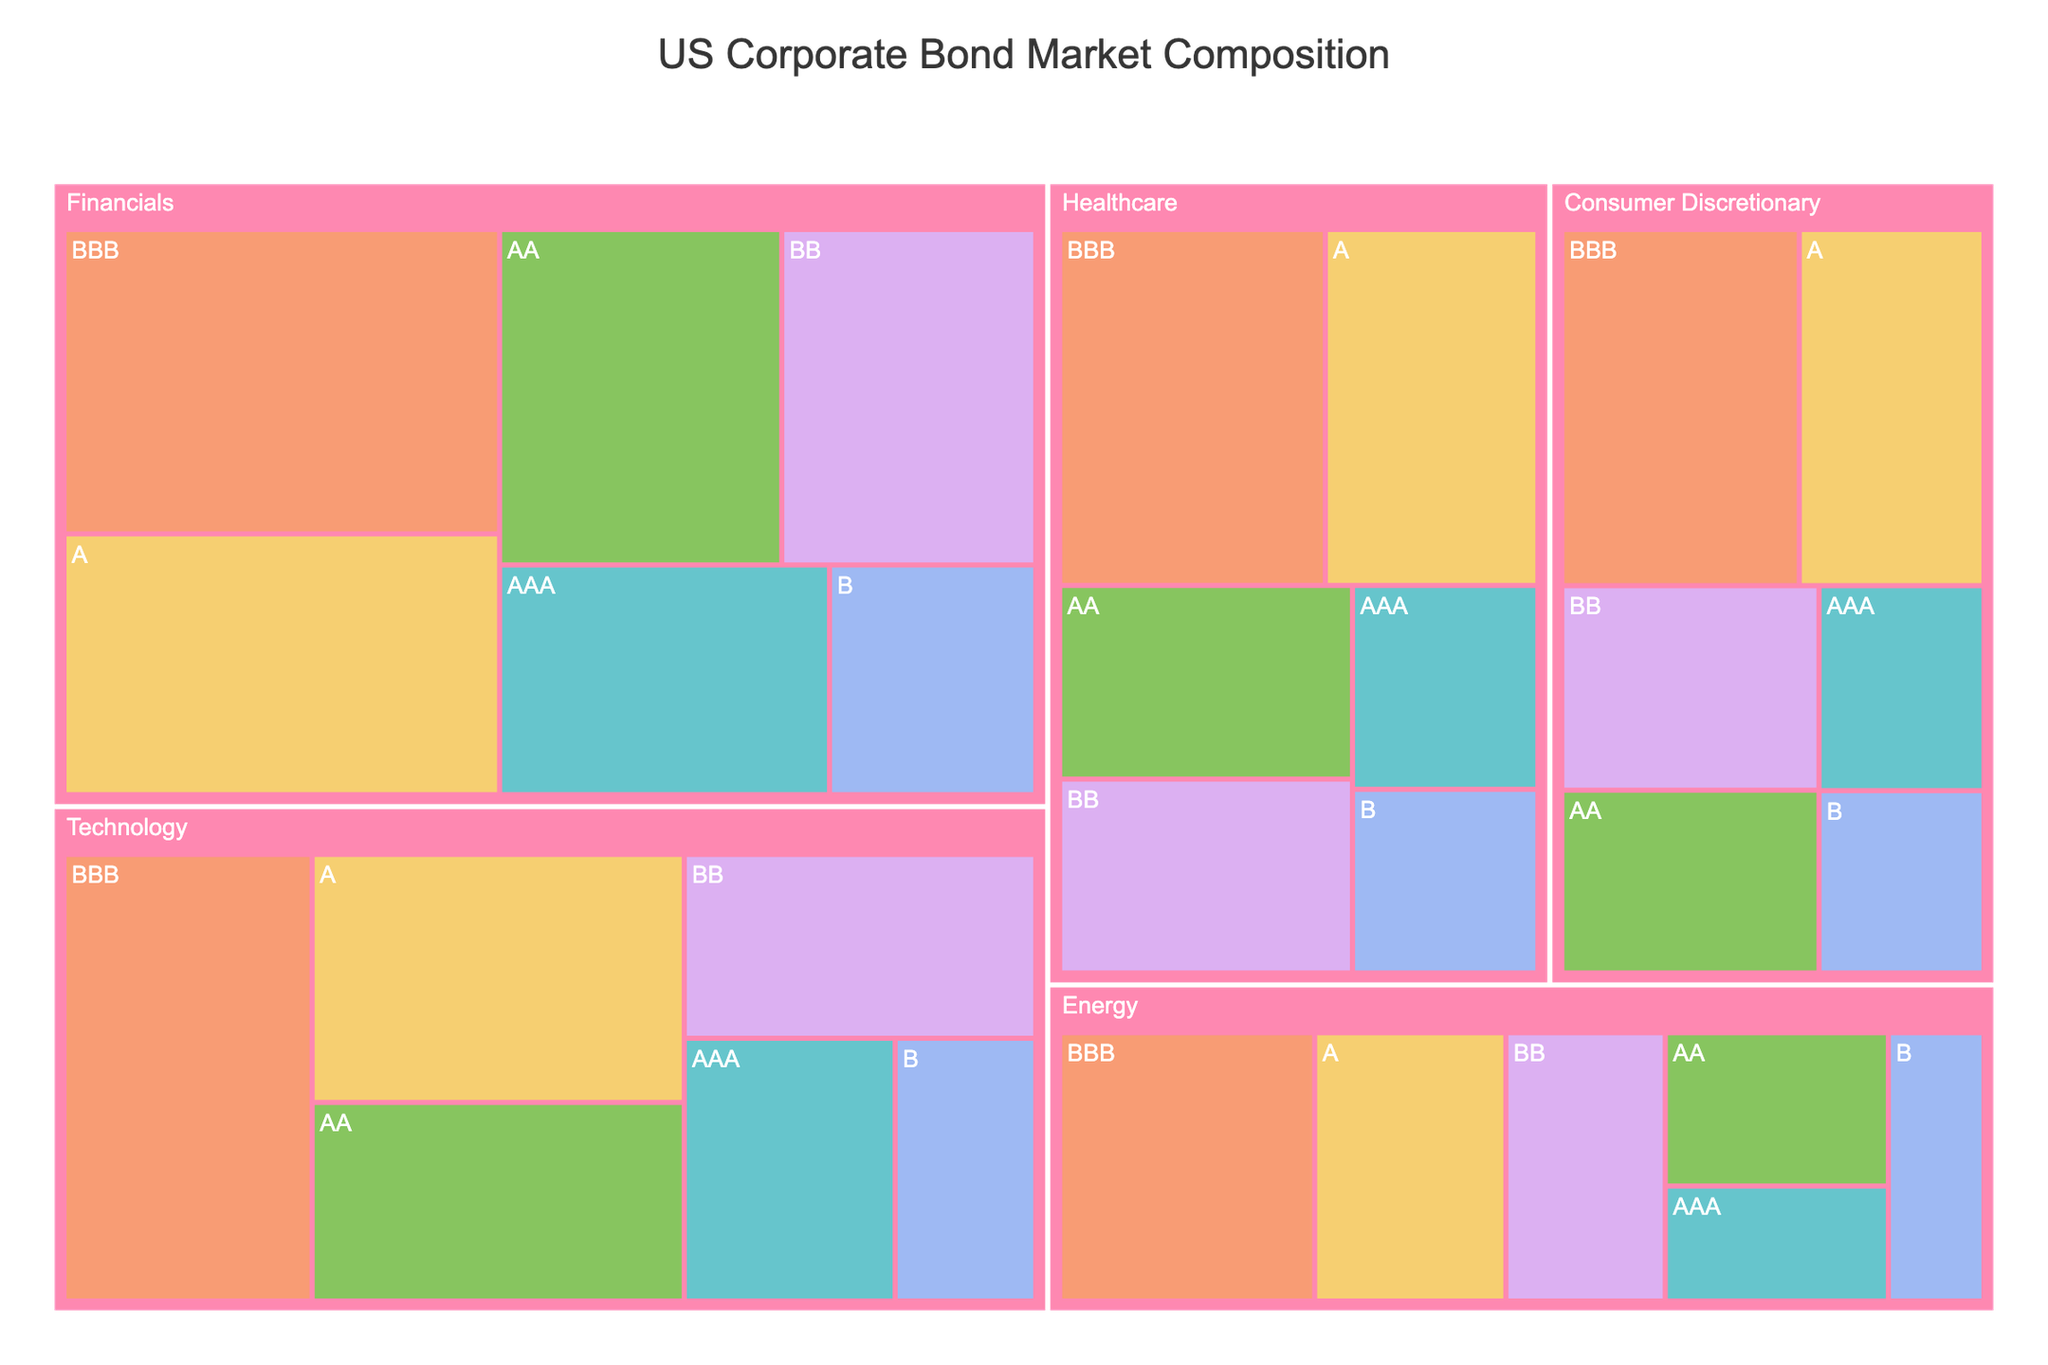What is the title of the treemap? The title of the treemap is located at the top of the figure and is designated to give a succinct description of what the treemap represents. In this case, it simply states what the treemap is about.
Answer: US Corporate Bond Market Composition Which credit rating has the highest market value in the Technology industry? By examining the treemap's segments, the largest block within the Technology industry corresponds to the credit rating with the highest assigned market value.
Answer: BBB What is the total market value of bonds in the Energy industry? To determine the total market value of bonds in the Energy industry, sum the market values of all credit ratings within that industry: 150 + 200 + 300 + 400 + 250 + 150 = 1450.
Answer: 1450 How does the market value of AAA-rated bonds in Financials compare to AAA-rated bonds in Technology? Compare the market values of the AAA-rated segments within the Financials and Technology industries as shown on the treemap. Financials: 400, Technology: 300. Financials has a higher value.
Answer: Financials Which industry has the largest market value for BB-rated bonds? The industry with the largest segment for BB-rated bonds in the treemap has the highest market value. Inspecting the BB-rated segments across all industries, Financials appear largest.
Answer: Financials List the industries in decreasing order of the total market value of BBB-rated bonds. To arrange the industries by the total market value of BBB-rated bonds, compare the sizes of the BBB segments within each industry. Financials: 700, Technology: 600, Healthcare: 500, Consumer Discretionary: 450, Energy: 400.
Answer: Financials, Technology, Healthcare, Consumer Discretionary, Energy What is the average market value of AAA-rated bonds across all industries? To find this average, sum the market values of AAA-rated bonds in each industry and then divide by the number of industries: (150 + 300 + 400 + 200 + 180) / 5 = 1230 / 5 = 246.
Answer: 246 Is the market value of A-rated bonds in Consumer Discretionary greater than in Healthcare? Compare the market values of A-rated segments for these two industries. Consumer Discretionary: 350, Healthcare: 400. Consumer Discretionary is not greater.
Answer: No What is the largest market value segment within the entire treemap? The largest market value segment in the treemap is identified by the size of the blocks; the block with the biggest area represents the highest market value. Upon inspection, BBB-rated bonds in Financials are the largest.
Answer: BBB-rated bonds in Financials 